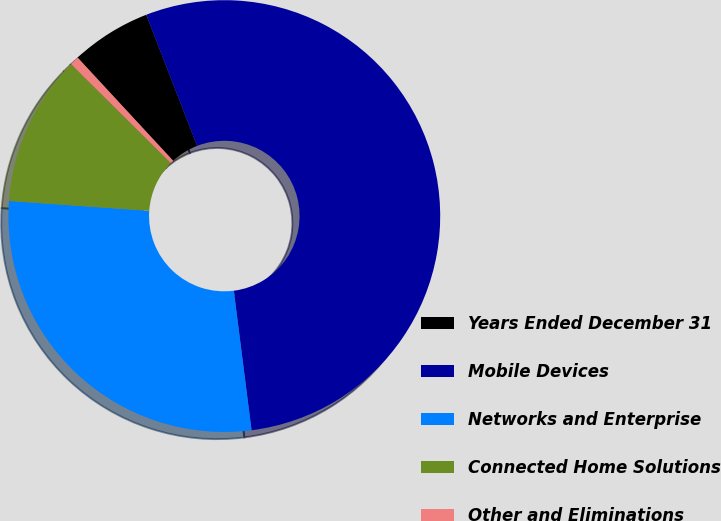<chart> <loc_0><loc_0><loc_500><loc_500><pie_chart><fcel>Years Ended December 31<fcel>Mobile Devices<fcel>Networks and Enterprise<fcel>Connected Home Solutions<fcel>Other and Eliminations<nl><fcel>6.0%<fcel>53.88%<fcel>28.13%<fcel>11.32%<fcel>0.68%<nl></chart> 